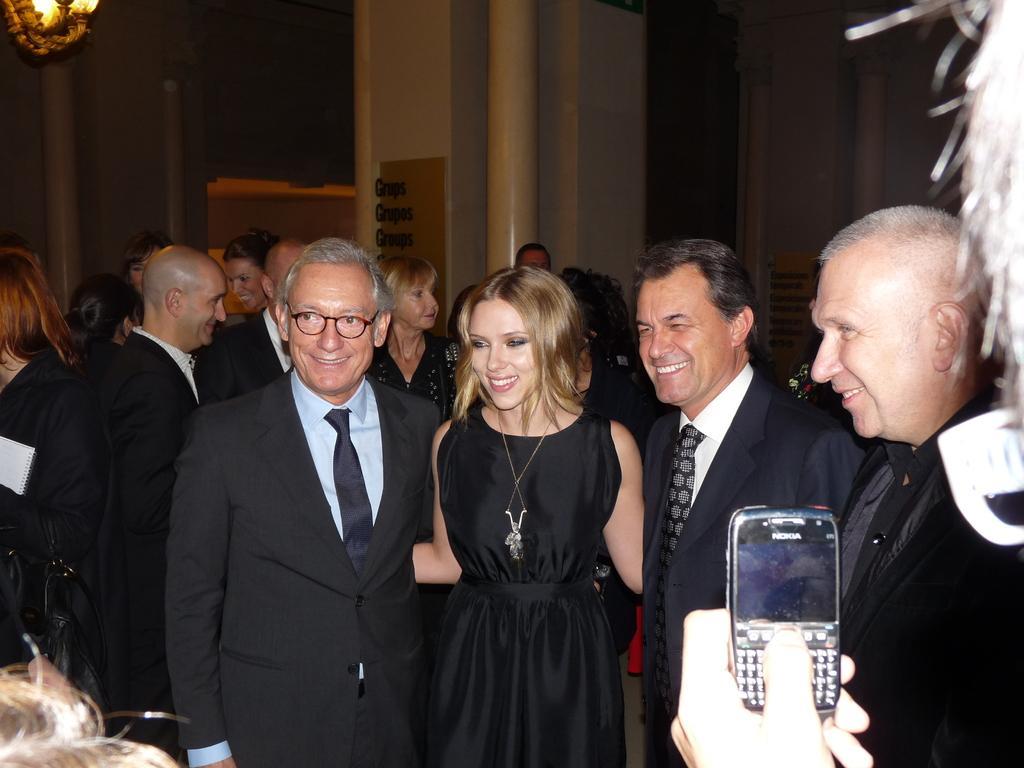How would you summarize this image in a sentence or two? There is a person holding a mobile and capturing the persons who are in black color dresses, smiling and standing. In the background, there are other persons in black color dresses standing on the floor, there is a pillar and there is wall. 